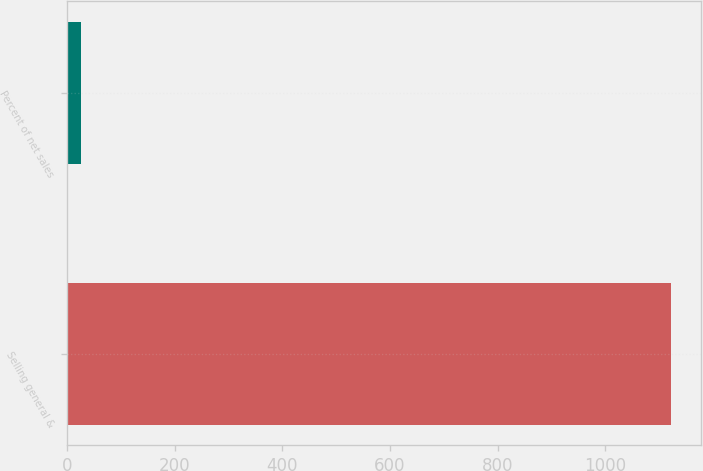<chart> <loc_0><loc_0><loc_500><loc_500><bar_chart><fcel>Selling general &<fcel>Percent of net sales<nl><fcel>1122<fcel>26.5<nl></chart> 